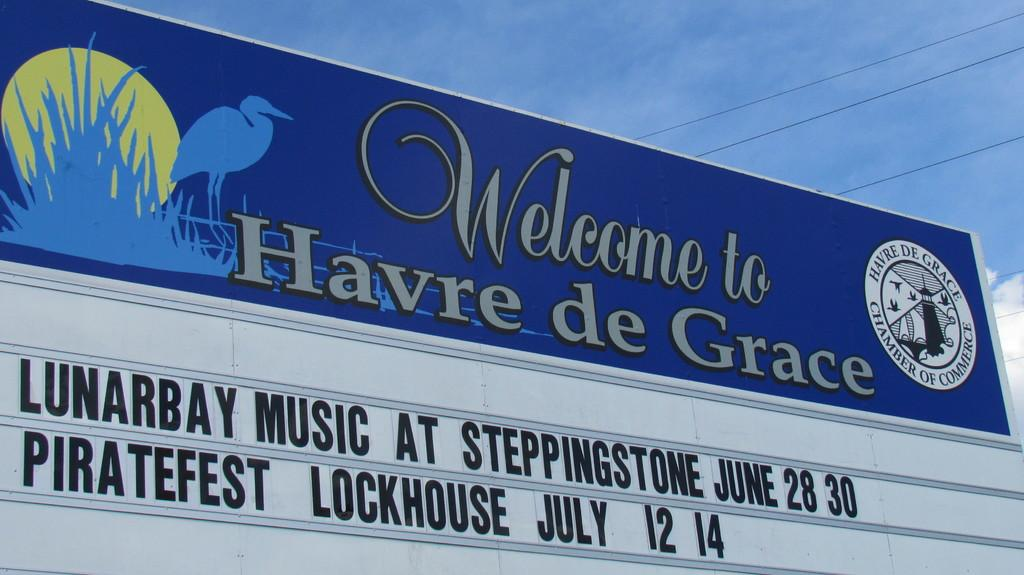<image>
Render a clear and concise summary of the photo. A blue and white sign for the Havre de Grace Chamber of Commerce, with a silhouetted egret against the setting sun. 